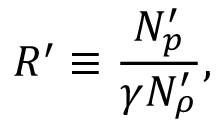<formula> <loc_0><loc_0><loc_500><loc_500>R ^ { \prime } \equiv \frac { N _ { p } ^ { \prime } } { \gamma N _ { \rho } ^ { \prime } } ,</formula> 